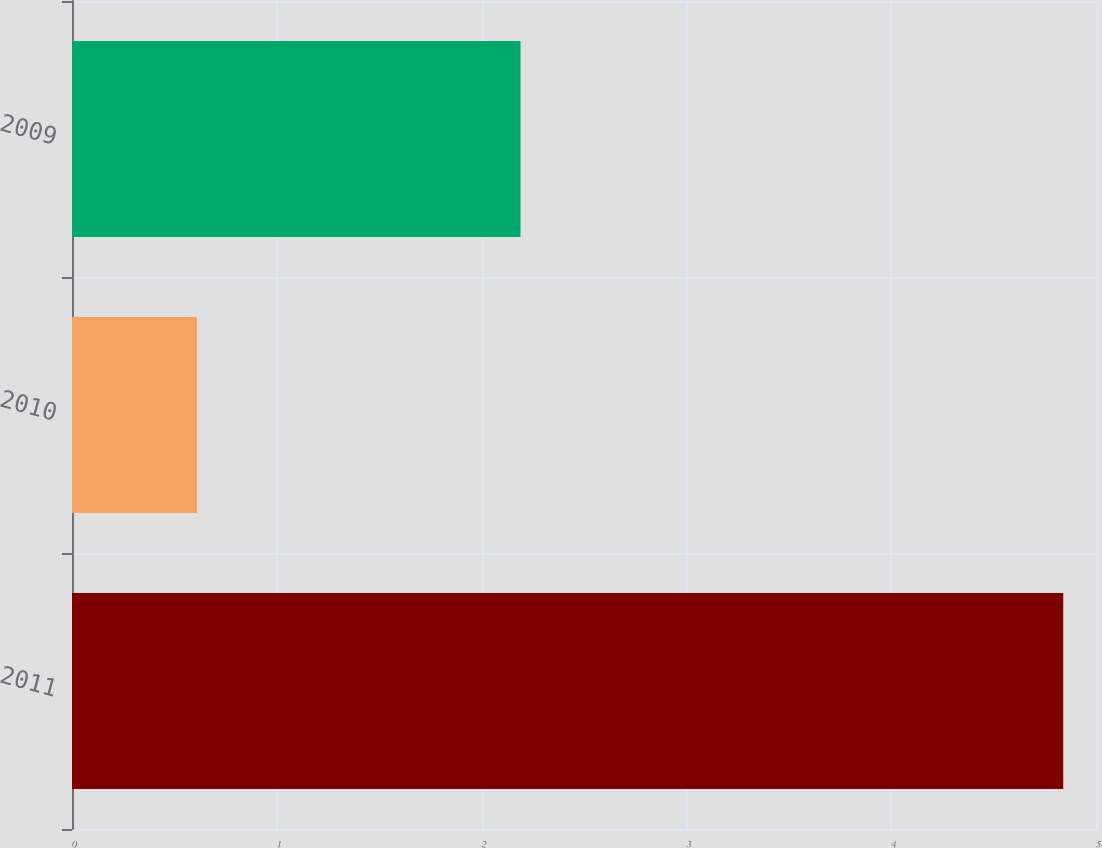<chart> <loc_0><loc_0><loc_500><loc_500><bar_chart><fcel>2011<fcel>2010<fcel>2009<nl><fcel>4.84<fcel>0.61<fcel>2.19<nl></chart> 